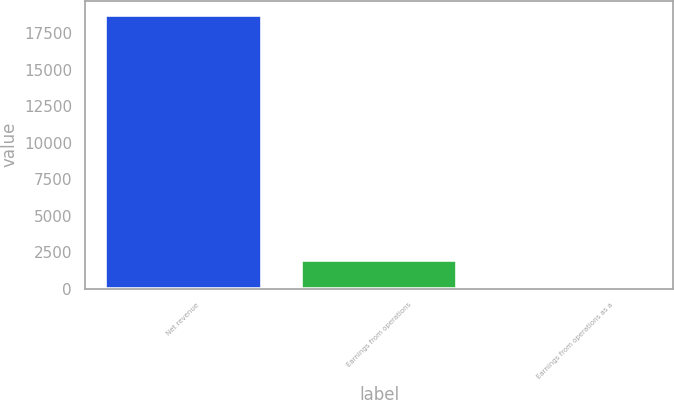Convert chart to OTSL. <chart><loc_0><loc_0><loc_500><loc_500><bar_chart><fcel>Net revenue<fcel>Earnings from operations<fcel>Earnings from operations as a<nl><fcel>18769<fcel>1980<fcel>10.5<nl></chart> 